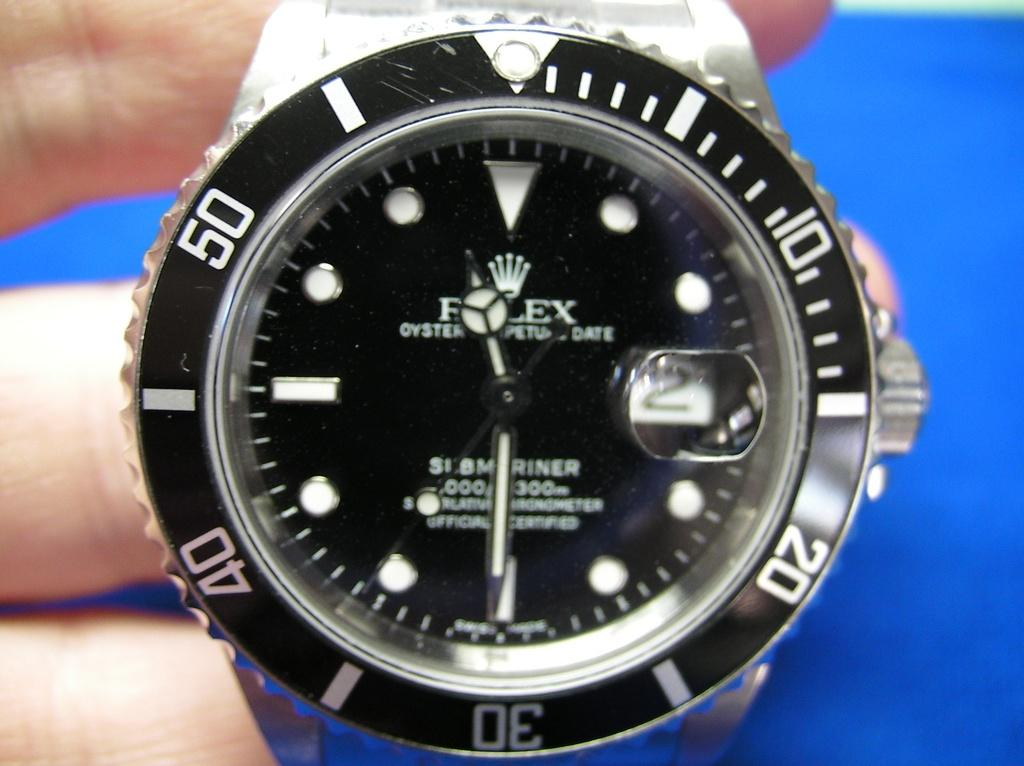Provide a one-sentence caption for the provided image. A black Rolex watch that has an Oyster Perpetual Date on it. 